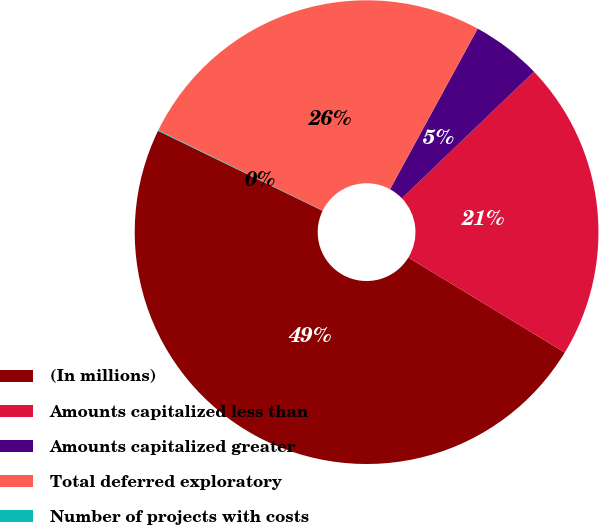<chart> <loc_0><loc_0><loc_500><loc_500><pie_chart><fcel>(In millions)<fcel>Amounts capitalized less than<fcel>Amounts capitalized greater<fcel>Total deferred exploratory<fcel>Number of projects with costs<nl><fcel>48.51%<fcel>20.85%<fcel>4.89%<fcel>25.7%<fcel>0.05%<nl></chart> 